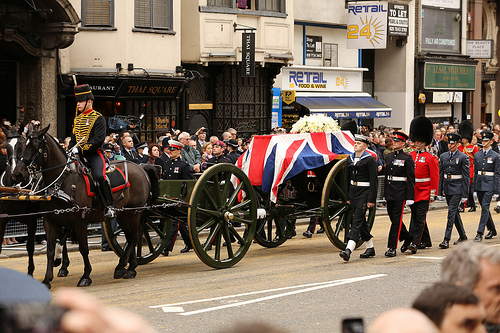What vehicle is the horse pulling? The horse is pulling a green wagon. 